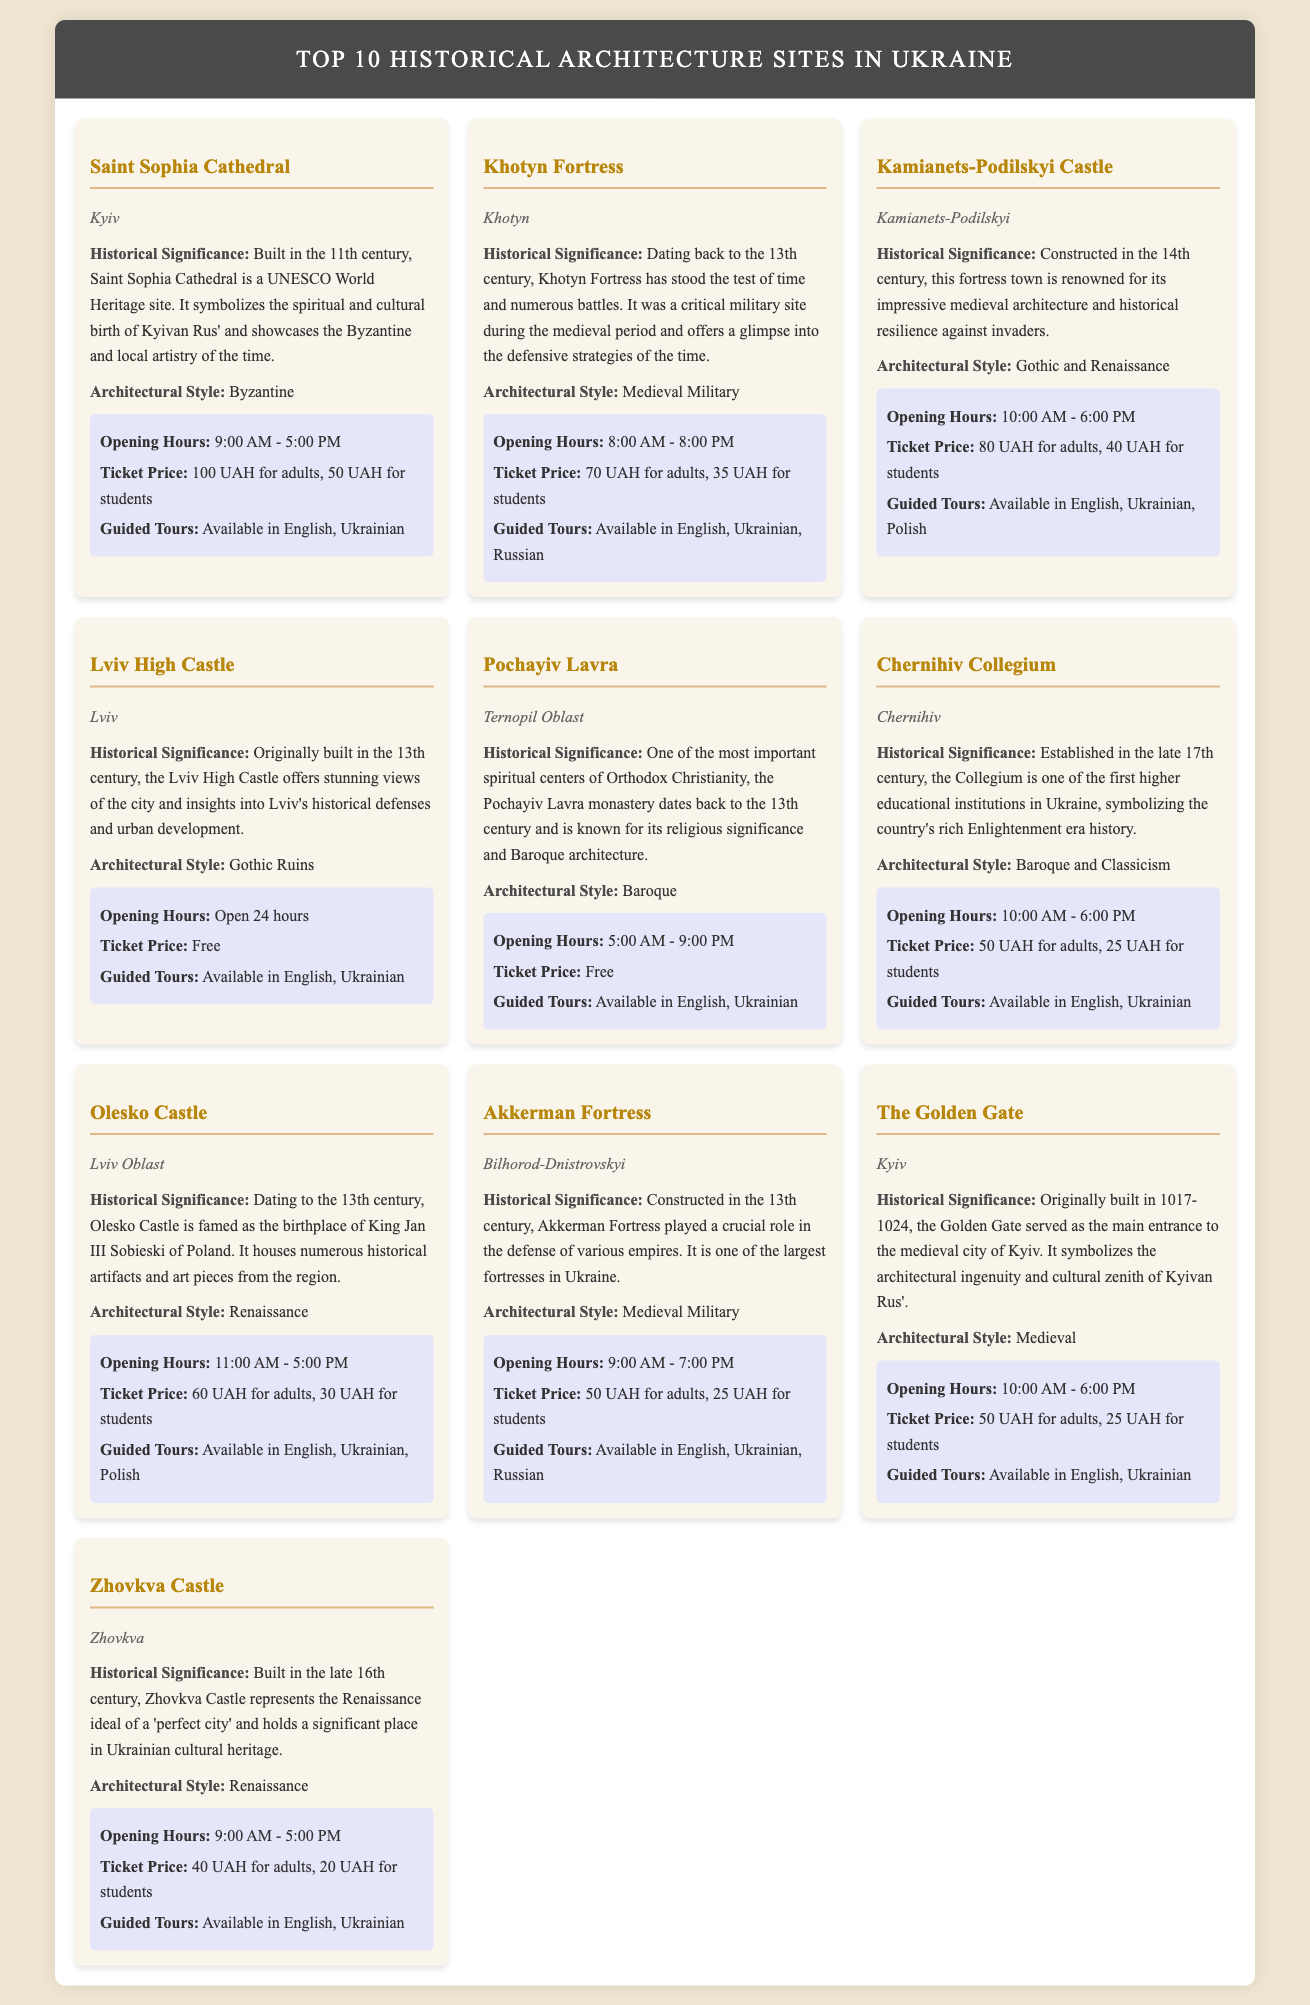what is the architectural style of Saint Sophia Cathedral? The architectural style of Saint Sophia Cathedral is mentioned as Byzantine in the document.
Answer: Byzantine what is the opening hour of Lviv High Castle? The document states that the opening hours for Lviv High Castle are 24 hours.
Answer: Open 24 hours how much is the ticket price for adults at Khotyn Fortress? The ticket price for adults at Khotyn Fortress is specified as 70 UAH in the document.
Answer: 70 UAH which century was Pochayiv Lavra established? According to the document, Pochayiv Lavra dates back to the 13th century.
Answer: 13th century how many architectural styles are listed for Kamianets-Podilskyi Castle? The document describes the architectural styles of Kamianets-Podilskyi Castle as Gothic and Renaissance, indicating there are two styles.
Answer: Two what is the historical significance of the Golden Gate? The historical significance of the Golden Gate is highlighted as serving as the main entrance to the medieval city of Kyiv.
Answer: Main entrance to the medieval city of Kyiv what is the location of Olesko Castle? The document lists Olesko Castle as being located in Lviv Oblast.
Answer: Lviv Oblast which site offers guided tours in Polish? The document mentions that Kamianets-Podilskyi Castle offers guided tours in Polish.
Answer: Kamianets-Podilskyi Castle what style of architecture does Zhovkva Castle represent? The architectural style represented by Zhovkva Castle is indicated as Renaissance according to the document.
Answer: Renaissance 